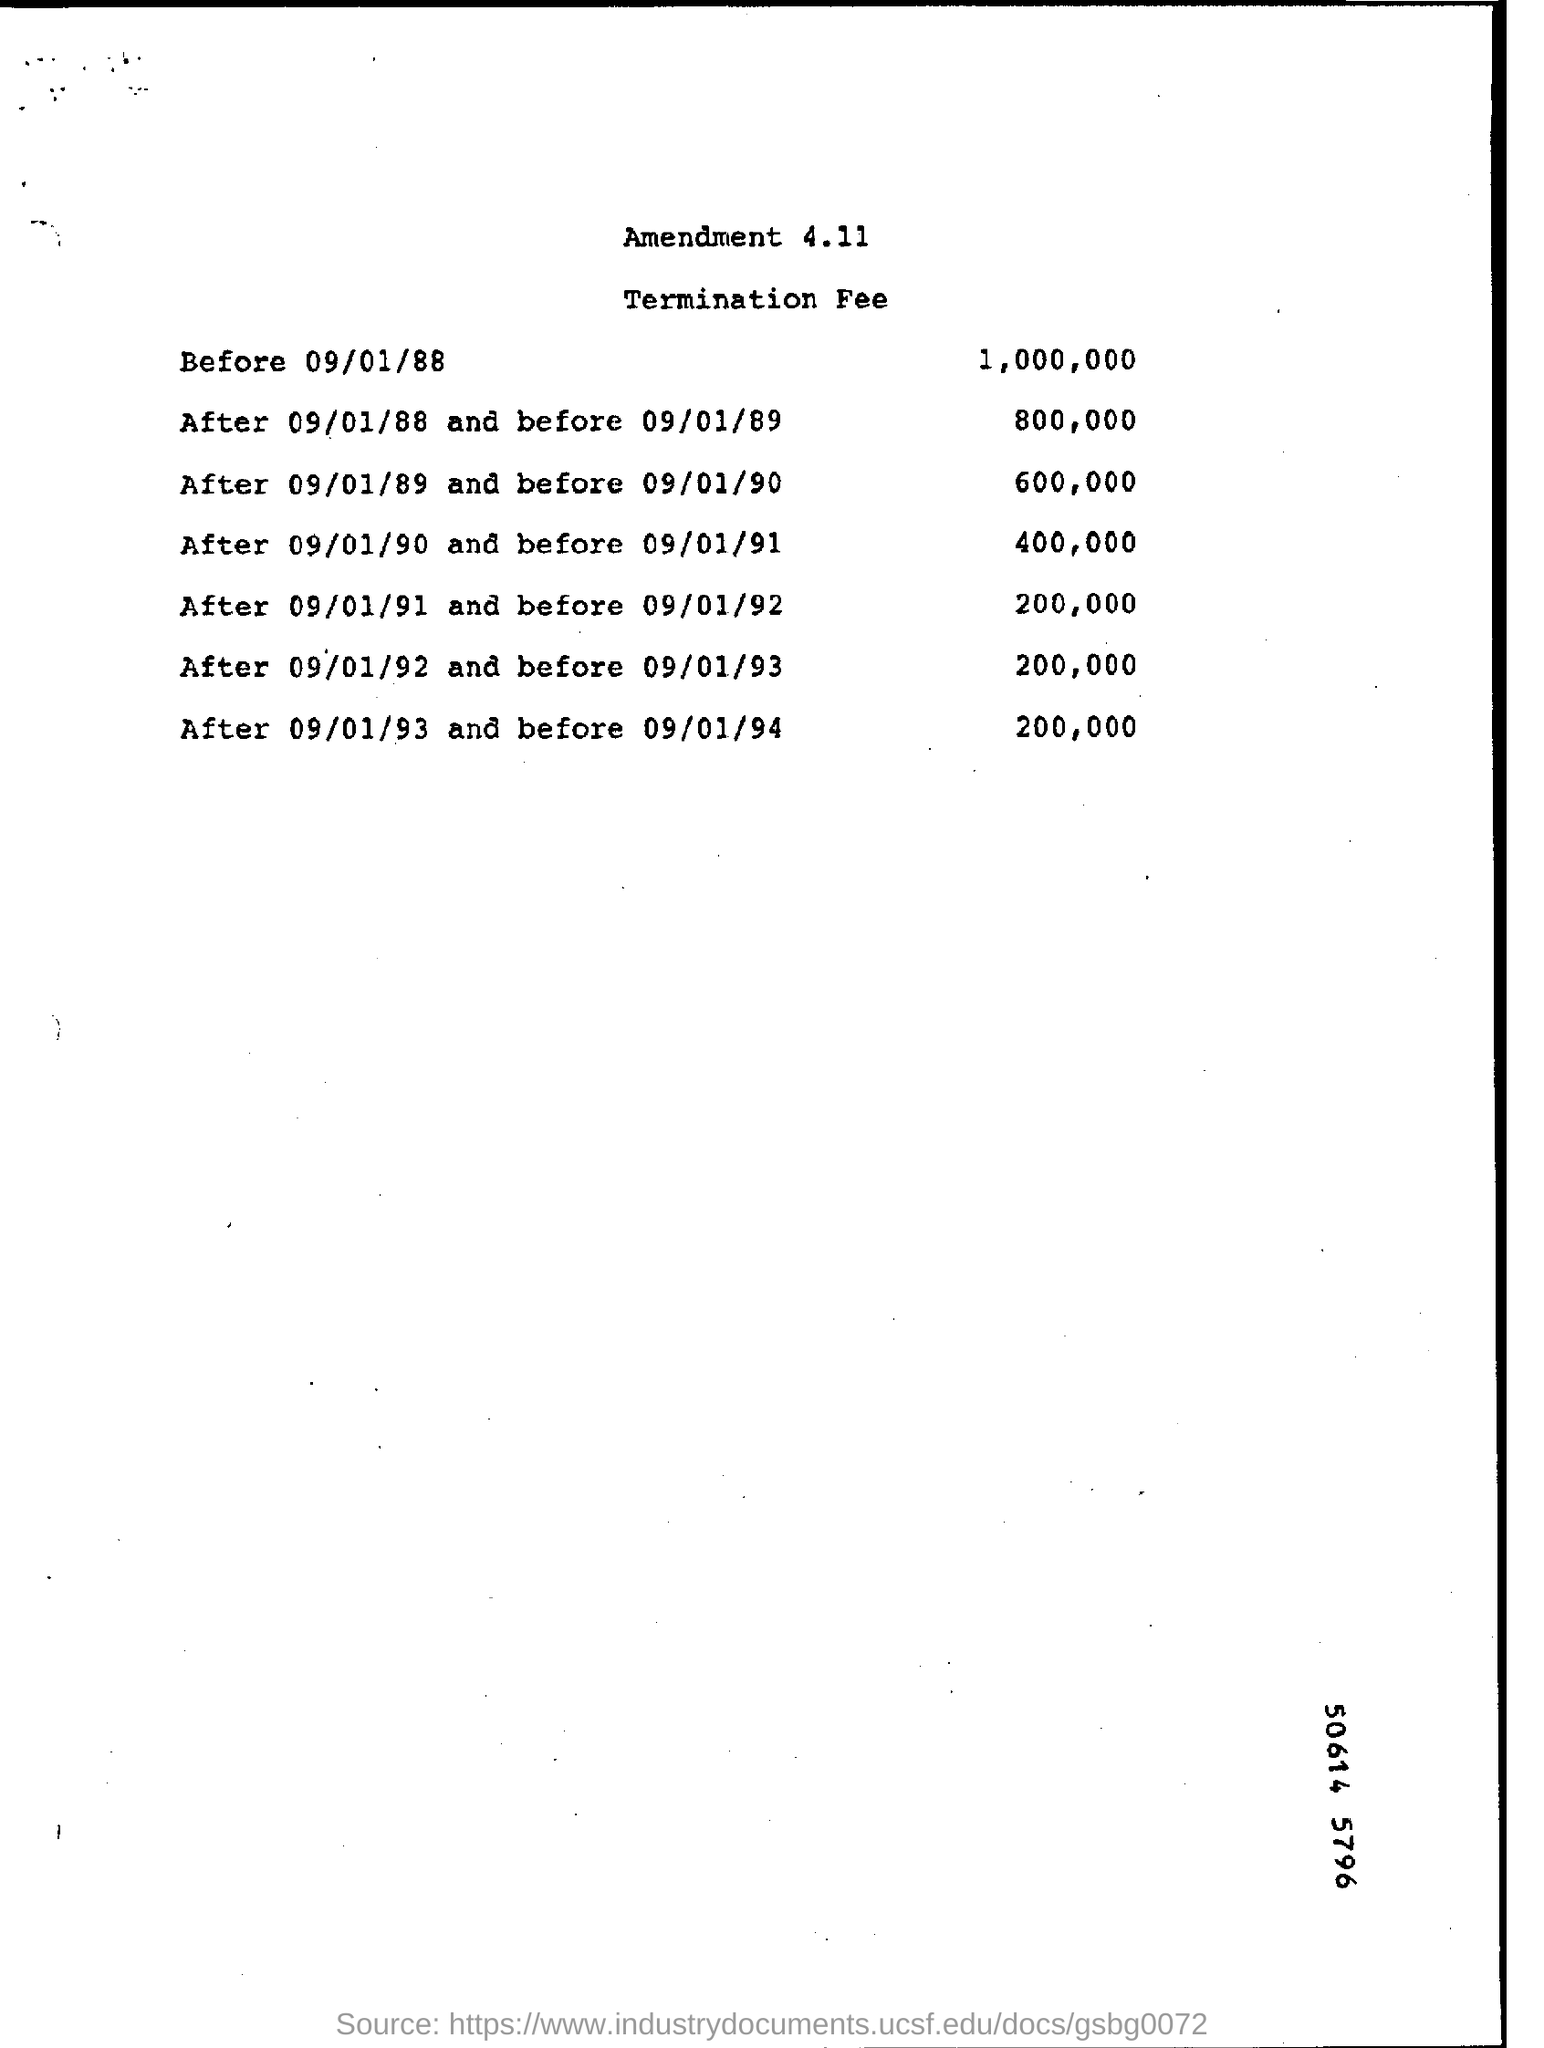What is the document about?
Offer a very short reply. Amendment 4.11. What is the fee before 09/01/88
Your answer should be compact. 1,000,000. What is the fee after 09/01/89 and before 09/01/90
Keep it short and to the point. 600,000. What is the fee after 09/01/92 and before 09/01/93
Your response must be concise. 200,000. What is the fee after 09/01/90 and before 09/01/91
Make the answer very short. 400,000. 